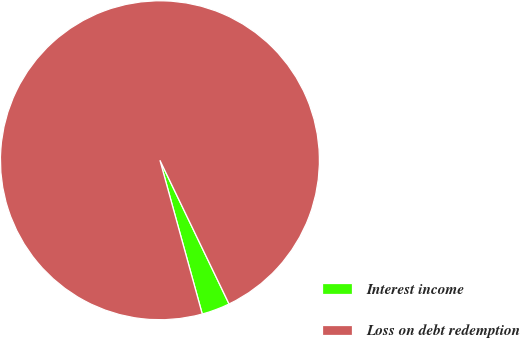Convert chart. <chart><loc_0><loc_0><loc_500><loc_500><pie_chart><fcel>Interest income<fcel>Loss on debt redemption<nl><fcel>2.86%<fcel>97.14%<nl></chart> 